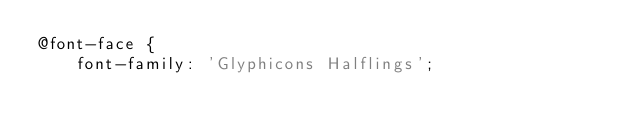Convert code to text. <code><loc_0><loc_0><loc_500><loc_500><_CSS_>@font-face {
    font-family: 'Glyphicons Halflings';
</code> 